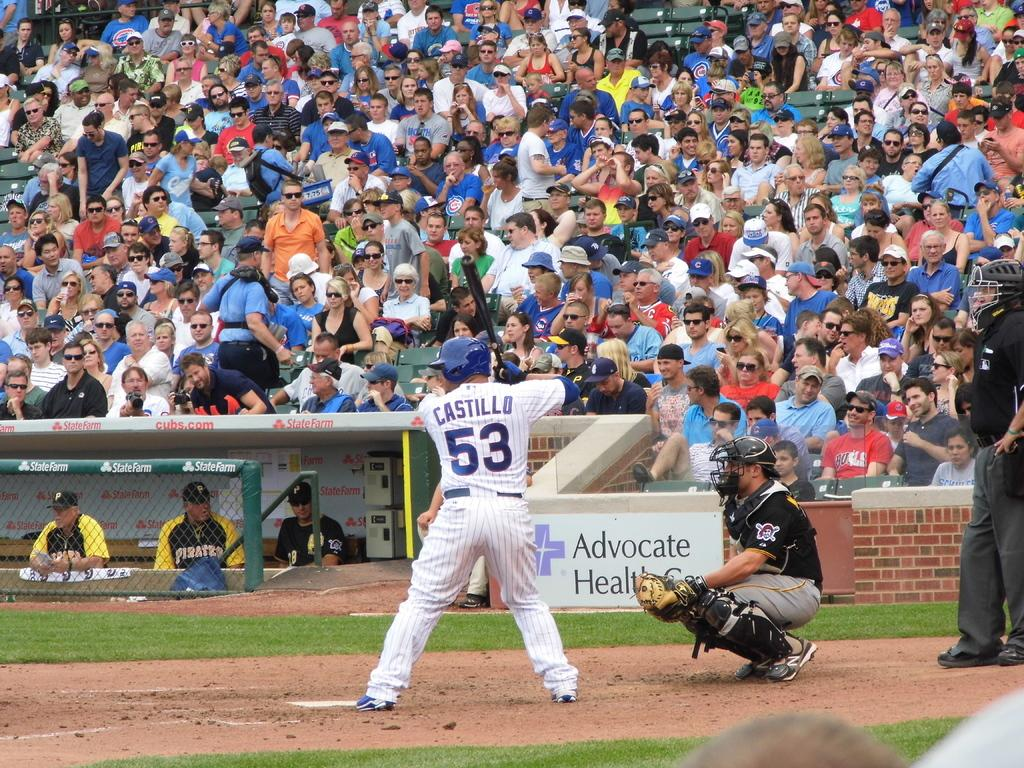<image>
Create a compact narrative representing the image presented. a baseball player named "Castillo" with the number 53 on the jersey is at bat on a baseball field 